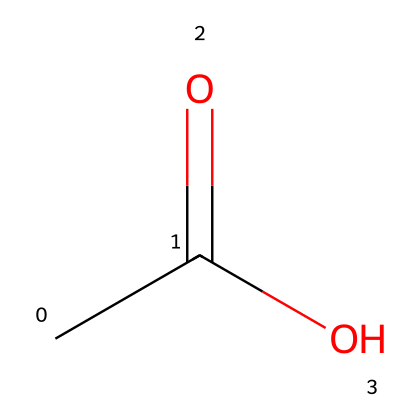What is the molecular formula of acetic acid? The molecular formula can be derived from the SMILES representation CC(=O)O, indicating the number of carbon (C), hydrogen (H), and oxygen (O) atoms. Here, there are 2 carbon atoms, 4 hydrogen atoms, and 2 oxygen atoms. Thus, the molecular formula is C2H4O2.
Answer: C2H4O2 How many carbon atoms are present in acetic acid? The SMILES representation CC(=O)O shows that there are two carbon (C) atoms represented by "CC". Therefore, there are 2 carbon atoms in acetic acid.
Answer: 2 What type of functional group is present in acetic acid? In the structure represented by the SMILES CC(=O)O, the "COOH" group signifies a carboxylic acid functional group, which is characteristic of acids. Hence, acetic acid contains a carboxylic acid functional group.
Answer: carboxylic acid What is the total number of hydrogen atoms in acetic acid? Analyzing the SMILES representation CC(=O)O, it indicates the presence of 4 hydrogen atoms attached to the two carbons and the carboxylic group. Thus, the total number of hydrogen atoms is 4.
Answer: 4 What is the bond type between the carbon and oxygen in the carbonyl group? The notation C(=O) in the SMILES representation indicates a double bond between the first carbon (C) and the oxygen (O) of the carbonyl group. In a carbonyl group, this is specifically a carbon-oxygen double bond.
Answer: double bond What property allows acetic acid to act as an acid? Acetic acid acts as an acid due to the presence of hydrogen in its carboxylic group (COOH), which is capable of donating a proton (H+) to a base. This proton donation is what characterizes its acidic nature.
Answer: proton donor What is the significance of the presence of the carboxyl group in acetic acid? The carboxyl group (COOH) in acetic acid is responsible for its acidic properties, including its ability to donate protons and its solubility in water, thereby affecting its behavior in solutions and biological systems.
Answer: acidic properties 